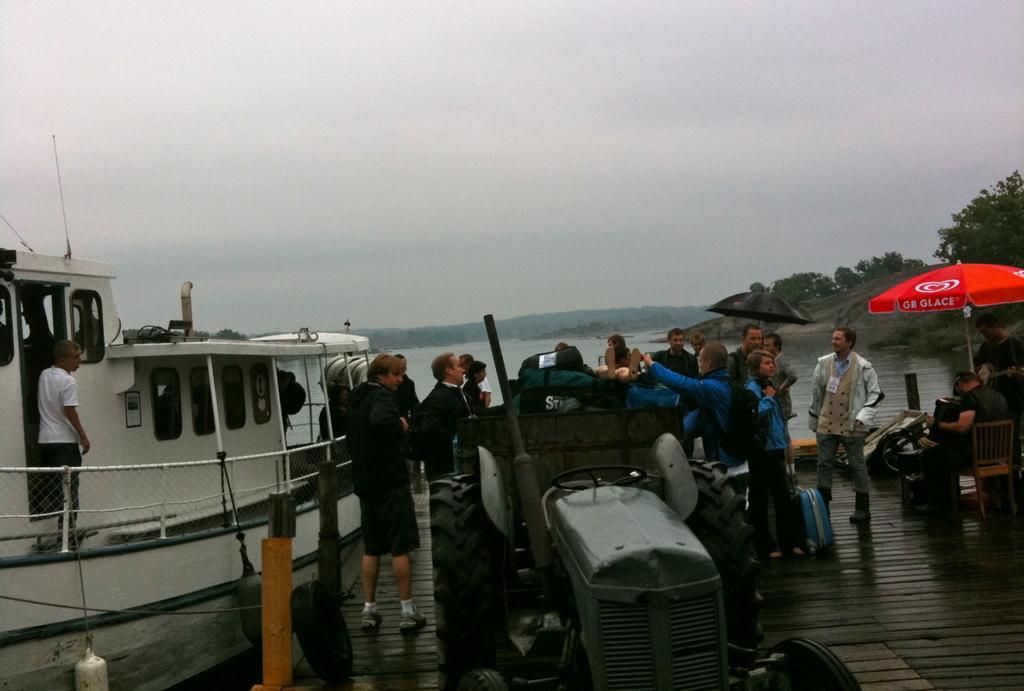Could you give a brief overview of what you see in this image? In this image we can see a vehicle and also a few people standing on the path with luggages. On the right there is a person sitting on the chair under the red color tint. On the left we can see a man standing in the boat. In the background we can see the trees, hills and also the river. Sky is also visible. 